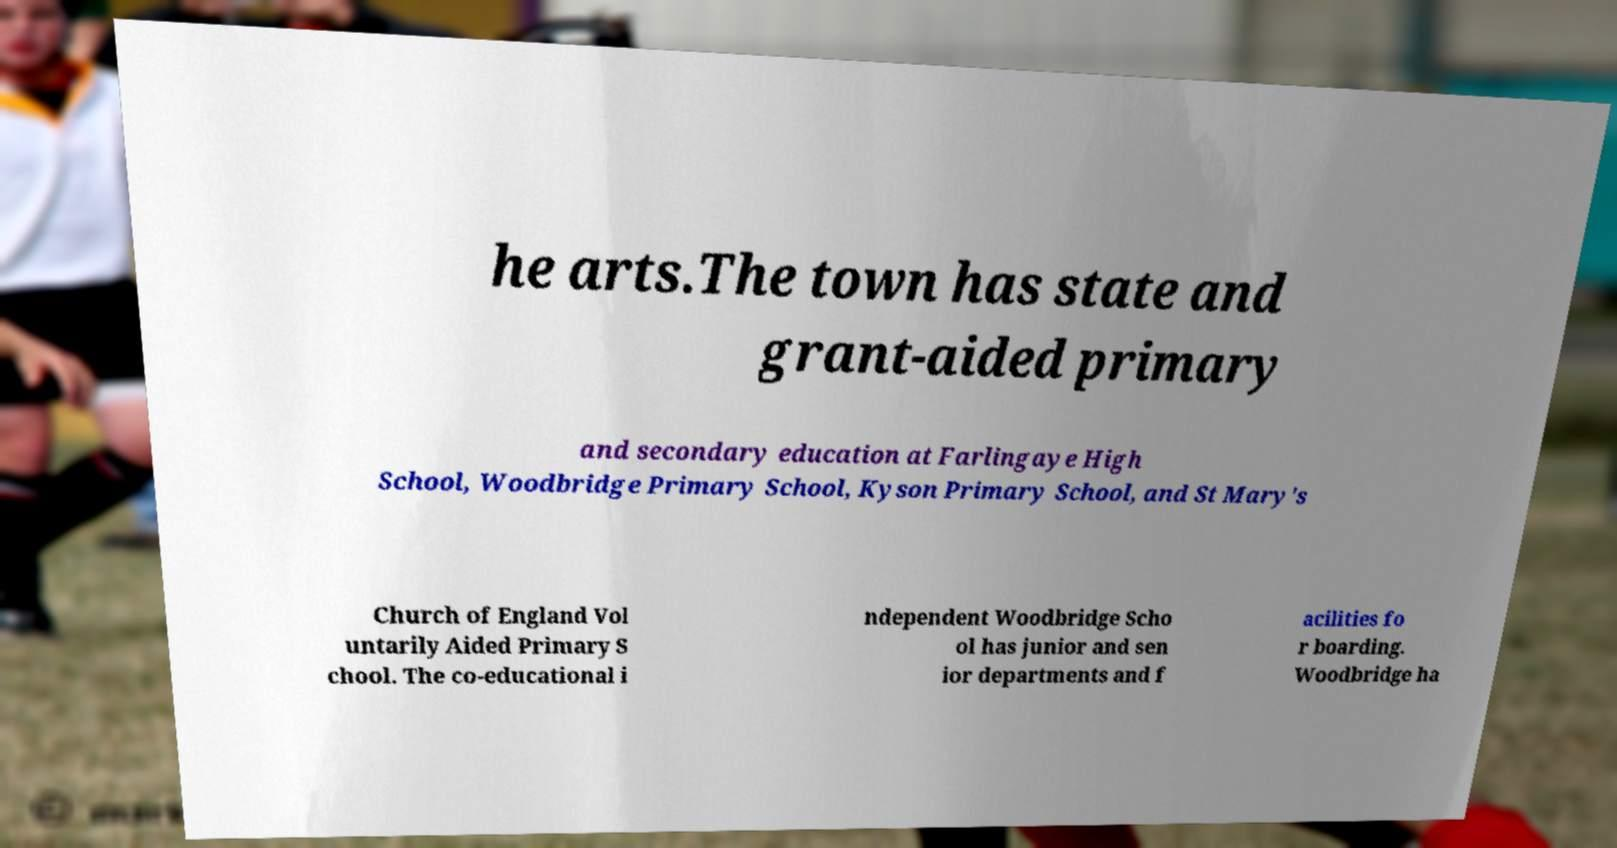For documentation purposes, I need the text within this image transcribed. Could you provide that? he arts.The town has state and grant-aided primary and secondary education at Farlingaye High School, Woodbridge Primary School, Kyson Primary School, and St Mary's Church of England Vol untarily Aided Primary S chool. The co-educational i ndependent Woodbridge Scho ol has junior and sen ior departments and f acilities fo r boarding. Woodbridge ha 